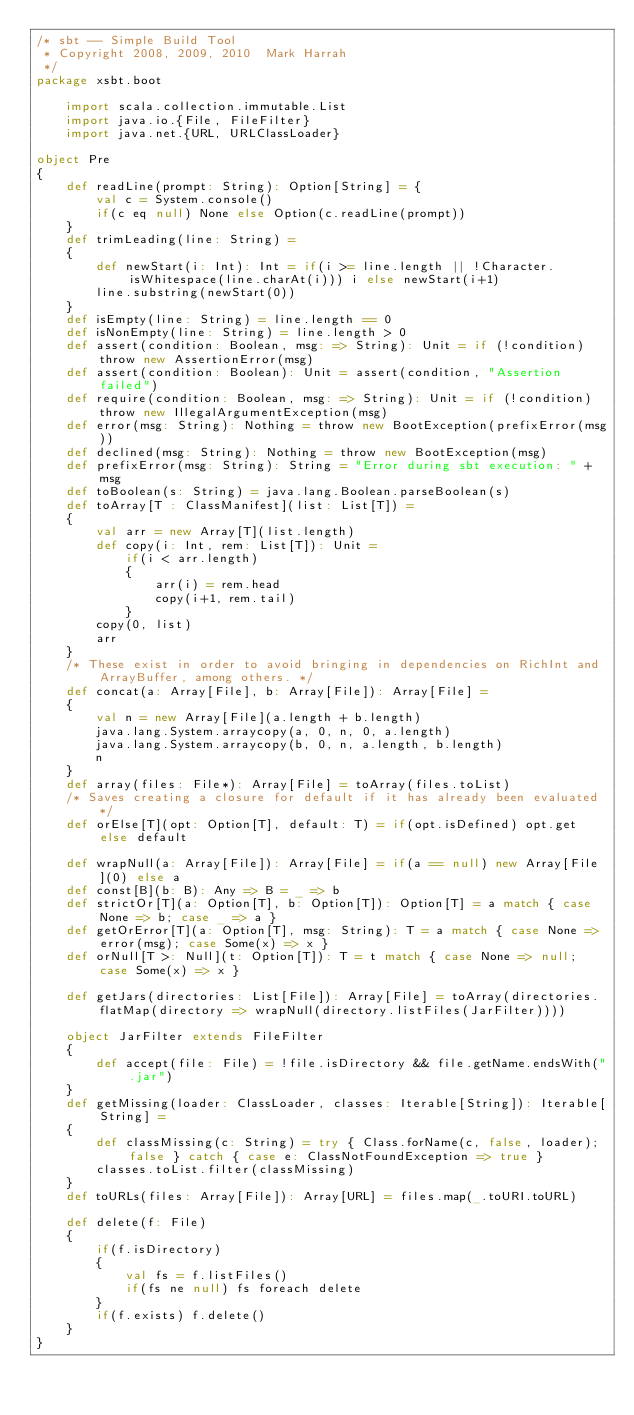Convert code to text. <code><loc_0><loc_0><loc_500><loc_500><_Scala_>/* sbt -- Simple Build Tool
 * Copyright 2008, 2009, 2010  Mark Harrah
 */
package xsbt.boot

	import scala.collection.immutable.List
	import java.io.{File, FileFilter}
	import java.net.{URL, URLClassLoader}

object Pre
{
	def readLine(prompt: String): Option[String] = {
		val c = System.console()
		if(c eq null) None else Option(c.readLine(prompt))
	}
	def trimLeading(line: String) =
	{
		def newStart(i: Int): Int = if(i >= line.length || !Character.isWhitespace(line.charAt(i))) i else newStart(i+1)
		line.substring(newStart(0))
	}
	def isEmpty(line: String) = line.length == 0
	def isNonEmpty(line: String) = line.length > 0
	def assert(condition: Boolean, msg: => String): Unit = if (!condition) throw new AssertionError(msg)
	def assert(condition: Boolean): Unit = assert(condition, "Assertion failed")
	def require(condition: Boolean, msg: => String): Unit = if (!condition) throw new IllegalArgumentException(msg)
	def error(msg: String): Nothing = throw new BootException(prefixError(msg))
	def declined(msg: String): Nothing = throw new BootException(msg)
	def prefixError(msg: String): String = "Error during sbt execution: " + msg
	def toBoolean(s: String) = java.lang.Boolean.parseBoolean(s)
	def toArray[T : ClassManifest](list: List[T]) =
	{
		val arr = new Array[T](list.length)
		def copy(i: Int, rem: List[T]): Unit =
			if(i < arr.length)
			{
				arr(i) = rem.head
				copy(i+1, rem.tail)
			}
		copy(0, list)
		arr
	}
	/* These exist in order to avoid bringing in dependencies on RichInt and ArrayBuffer, among others. */
	def concat(a: Array[File], b: Array[File]): Array[File] =
	{
		val n = new Array[File](a.length + b.length)
		java.lang.System.arraycopy(a, 0, n, 0, a.length)
		java.lang.System.arraycopy(b, 0, n, a.length, b.length)
		n
	}
	def array(files: File*): Array[File] = toArray(files.toList)
	/* Saves creating a closure for default if it has already been evaluated*/
	def orElse[T](opt: Option[T], default: T) = if(opt.isDefined) opt.get else default

	def wrapNull(a: Array[File]): Array[File] = if(a == null) new Array[File](0) else a
	def const[B](b: B): Any => B = _ => b
	def strictOr[T](a: Option[T], b: Option[T]): Option[T] = a match { case None => b; case _ => a }
	def getOrError[T](a: Option[T], msg: String): T = a match { case None => error(msg); case Some(x) => x }
	def orNull[T >: Null](t: Option[T]): T = t match { case None => null; case Some(x) => x }

	def getJars(directories: List[File]): Array[File] = toArray(directories.flatMap(directory => wrapNull(directory.listFiles(JarFilter))))

	object JarFilter extends FileFilter
	{
		def accept(file: File) = !file.isDirectory && file.getName.endsWith(".jar")
	}
	def getMissing(loader: ClassLoader, classes: Iterable[String]): Iterable[String] =
	{
		def classMissing(c: String) = try { Class.forName(c, false, loader); false } catch { case e: ClassNotFoundException => true }
		classes.toList.filter(classMissing)
	}
	def toURLs(files: Array[File]): Array[URL] = files.map(_.toURI.toURL)

	def delete(f: File)
	{
		if(f.isDirectory)
		{
			val fs = f.listFiles()
			if(fs ne null) fs foreach delete
		}
		if(f.exists) f.delete()
	}
}
</code> 